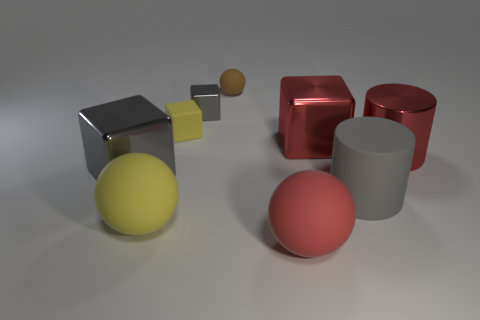There is a tiny object that is in front of the tiny brown matte ball and to the right of the tiny yellow object; what is its shape?
Your response must be concise. Cube. Is the red ball the same size as the gray matte object?
Provide a short and direct response. Yes. How many big matte things are to the right of the yellow ball?
Offer a terse response. 2. Are there an equal number of big gray matte things behind the tiny brown ball and red rubber spheres on the left side of the red shiny cube?
Give a very brief answer. No. There is a large thing to the left of the yellow ball; does it have the same shape as the brown thing?
Offer a terse response. No. There is a gray matte thing; is it the same size as the metallic object right of the big red metal cube?
Make the answer very short. Yes. How many other objects are there of the same color as the tiny shiny object?
Your answer should be very brief. 2. Are there any rubber cubes on the left side of the big gray matte cylinder?
Your answer should be compact. Yes. What number of things are big cyan rubber cylinders or metallic things right of the brown rubber sphere?
Make the answer very short. 2. There is a metallic cube right of the small gray metallic object; is there a tiny matte sphere that is behind it?
Provide a succinct answer. Yes. 